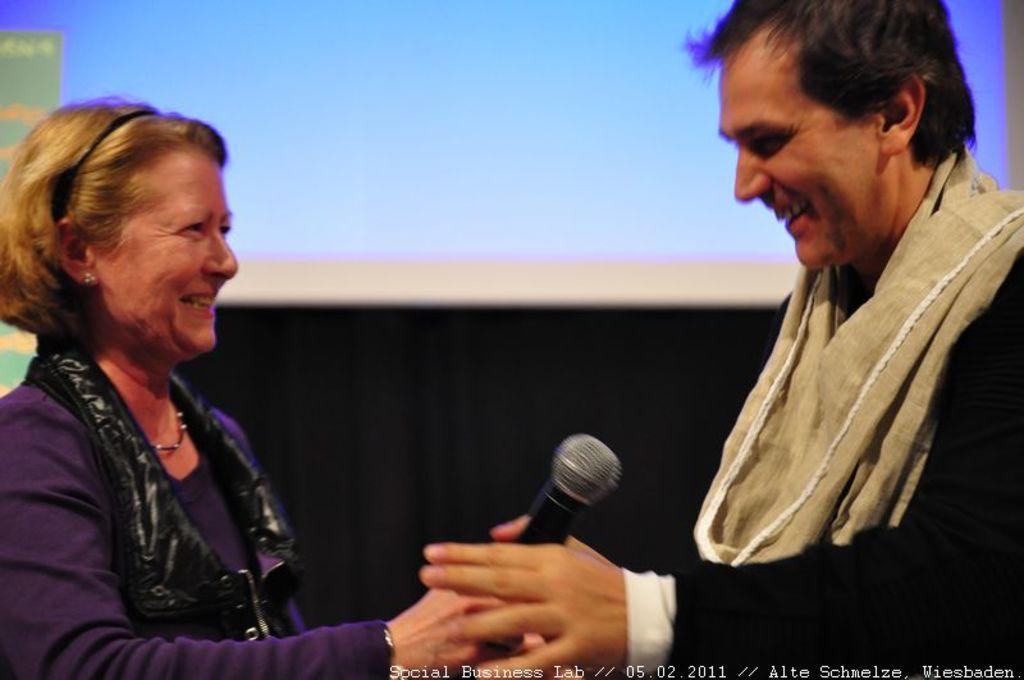Describe this image in one or two sentences. In this picture there were two persons, a woman is towards the left and a man towards the right. She is wearing a purple T shirt and a black jacket and he is wearing a black blazer and a cream scarf. Both are staring at each other and smiling. Woman is holding a mike. In the background there is a digital screen. 